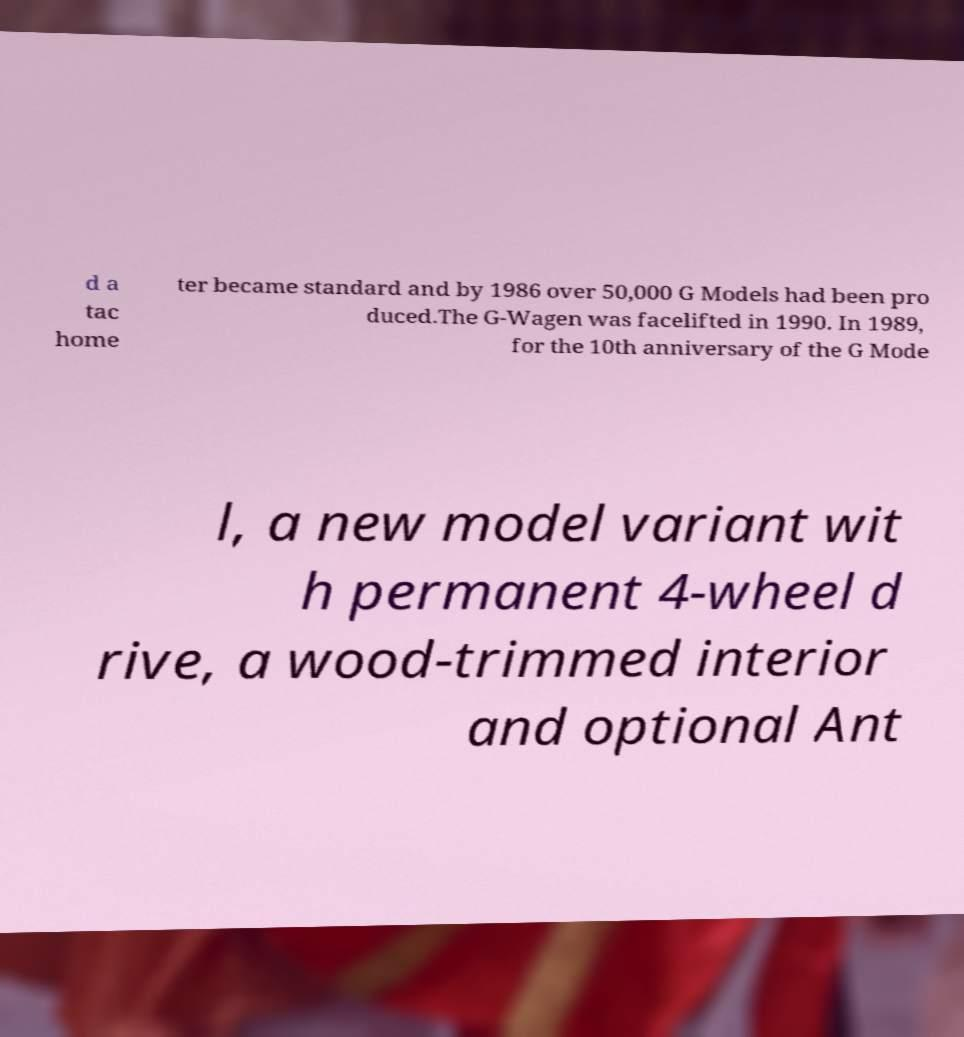Please identify and transcribe the text found in this image. d a tac home ter became standard and by 1986 over 50,000 G Models had been pro duced.The G-Wagen was facelifted in 1990. In 1989, for the 10th anniversary of the G Mode l, a new model variant wit h permanent 4-wheel d rive, a wood-trimmed interior and optional Ant 